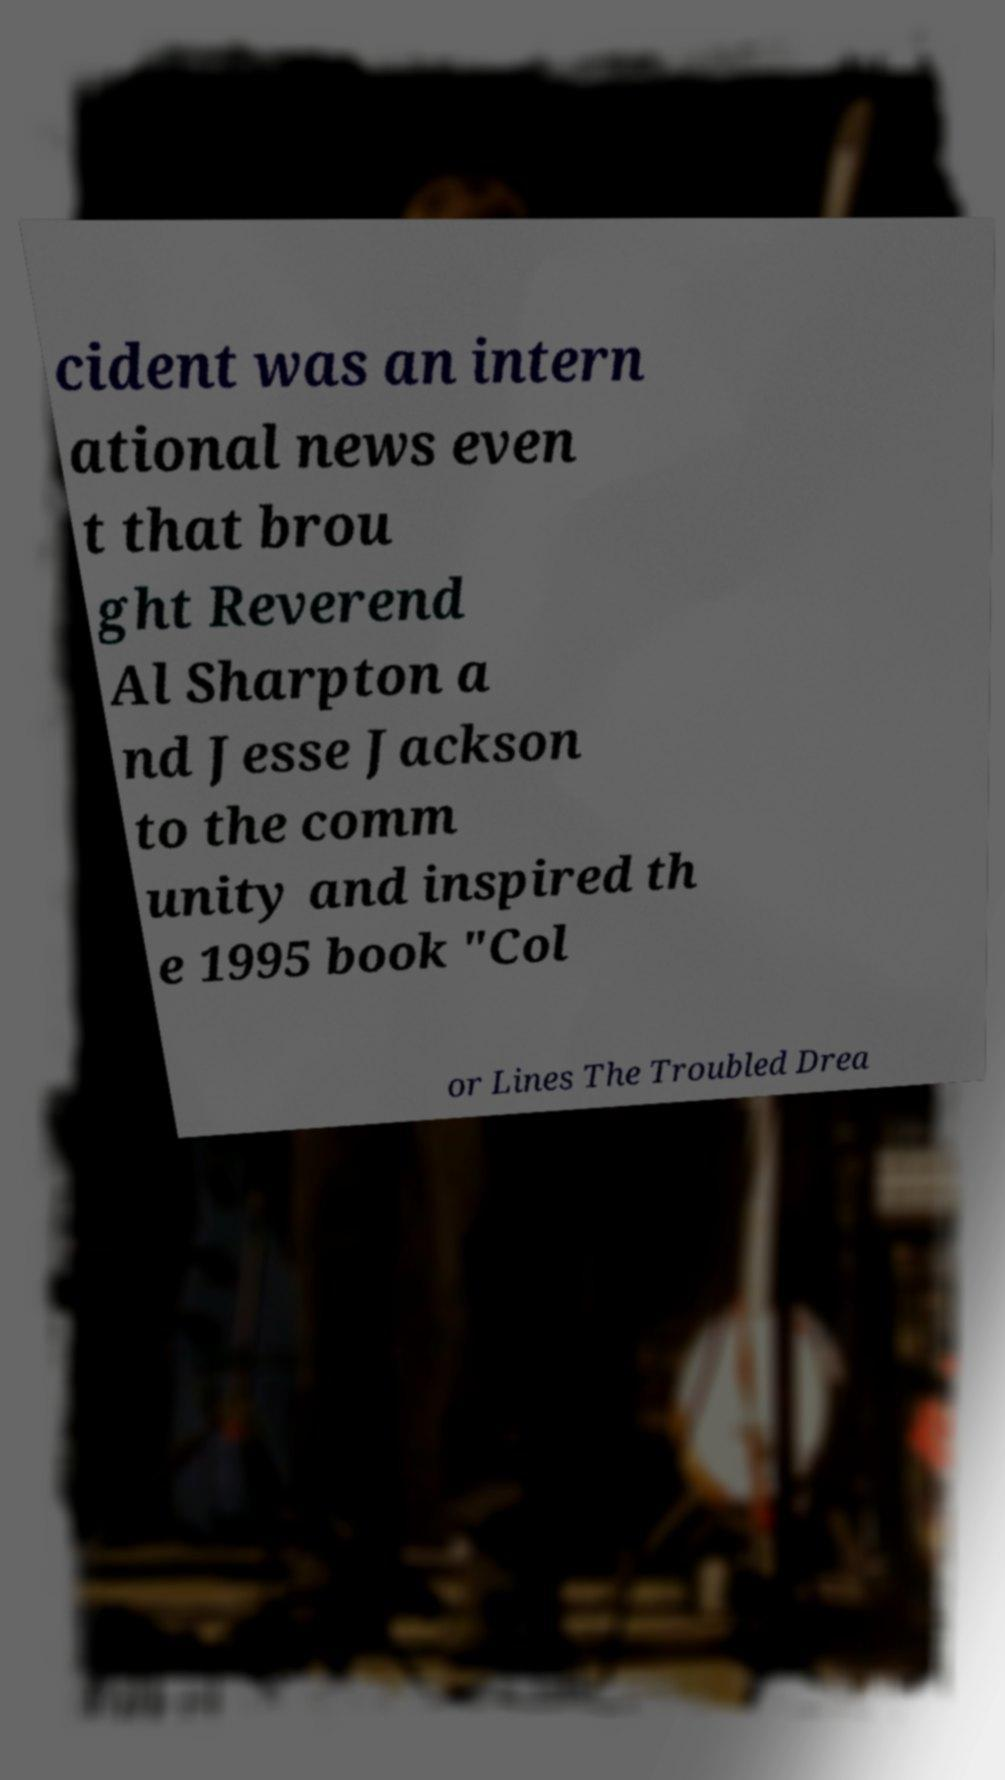What messages or text are displayed in this image? I need them in a readable, typed format. cident was an intern ational news even t that brou ght Reverend Al Sharpton a nd Jesse Jackson to the comm unity and inspired th e 1995 book "Col or Lines The Troubled Drea 